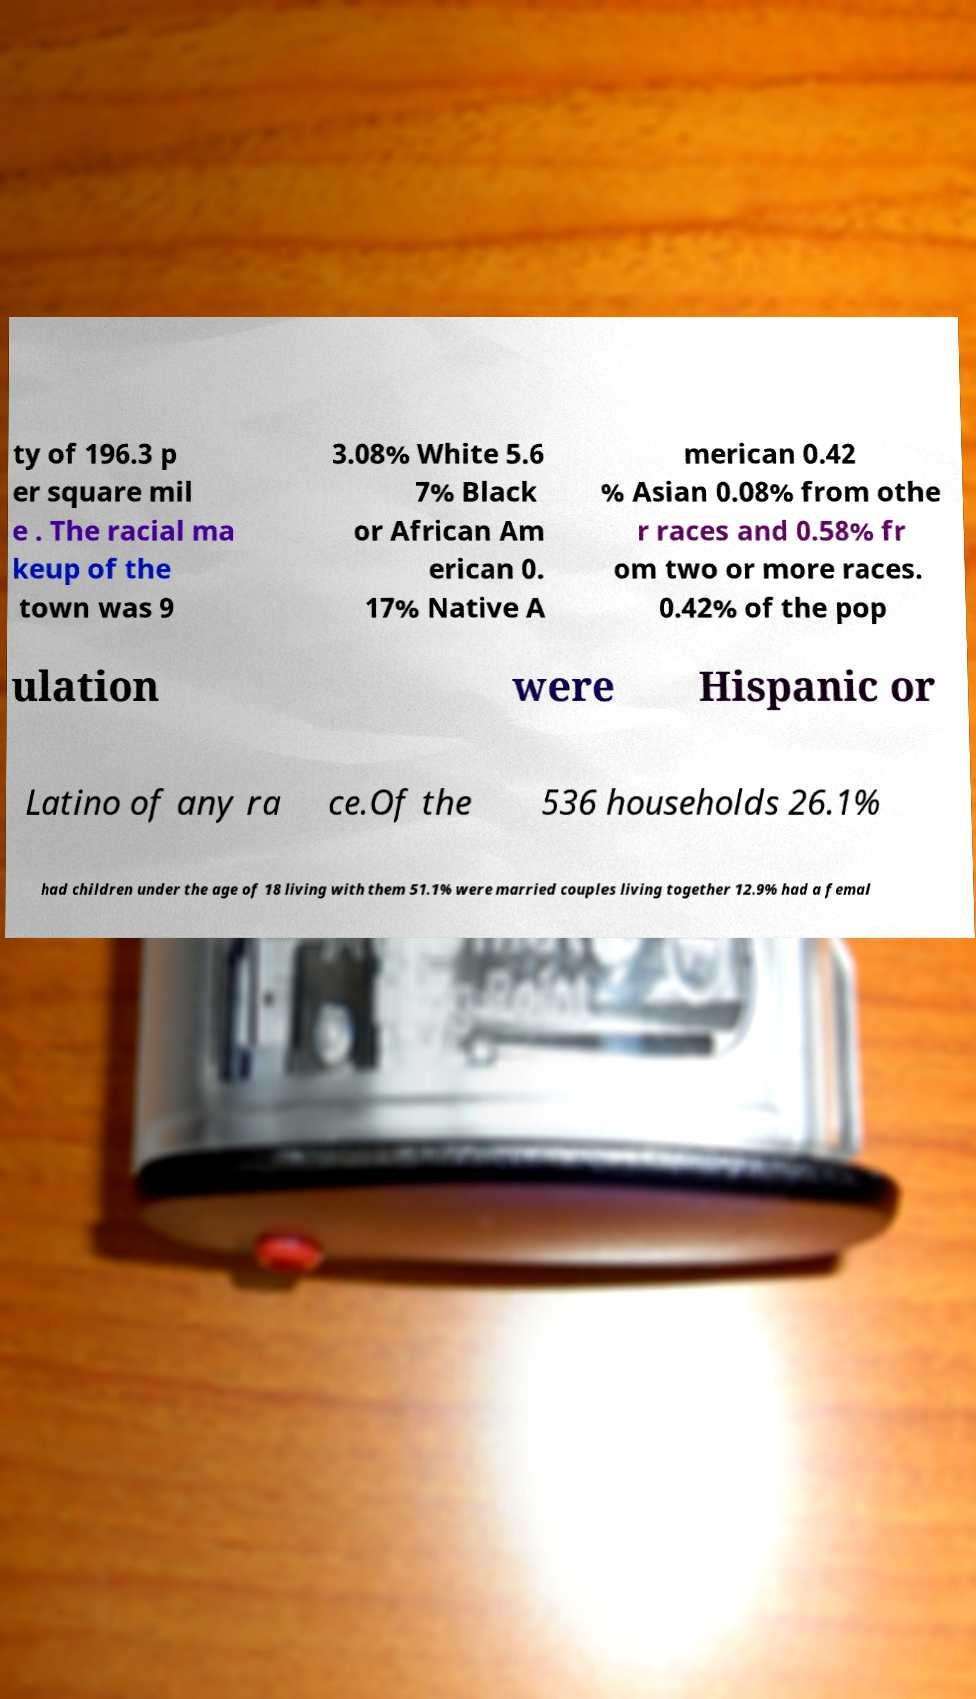For documentation purposes, I need the text within this image transcribed. Could you provide that? ty of 196.3 p er square mil e . The racial ma keup of the town was 9 3.08% White 5.6 7% Black or African Am erican 0. 17% Native A merican 0.42 % Asian 0.08% from othe r races and 0.58% fr om two or more races. 0.42% of the pop ulation were Hispanic or Latino of any ra ce.Of the 536 households 26.1% had children under the age of 18 living with them 51.1% were married couples living together 12.9% had a femal 